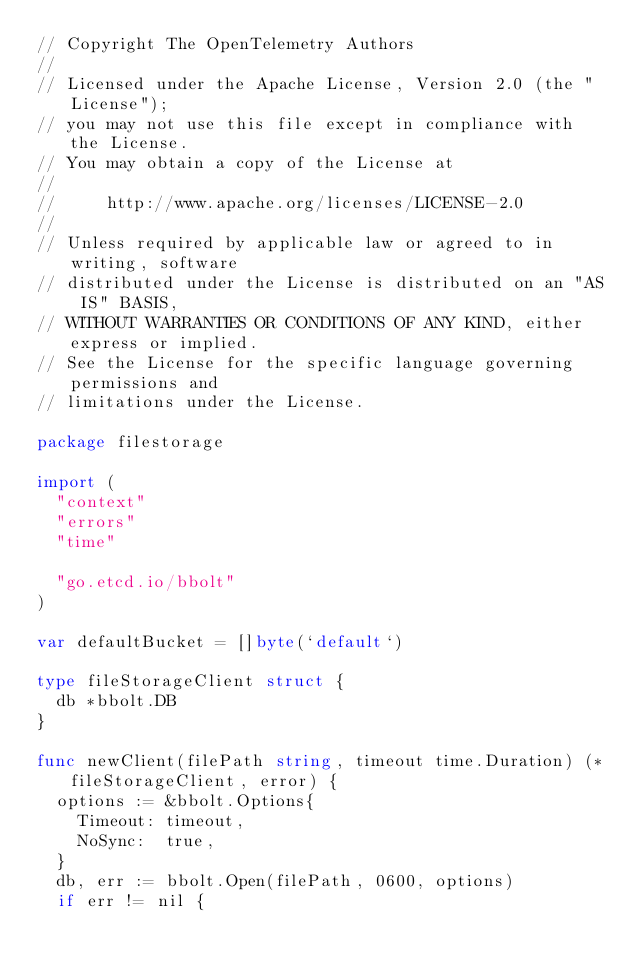<code> <loc_0><loc_0><loc_500><loc_500><_Go_>// Copyright The OpenTelemetry Authors
//
// Licensed under the Apache License, Version 2.0 (the "License");
// you may not use this file except in compliance with the License.
// You may obtain a copy of the License at
//
//     http://www.apache.org/licenses/LICENSE-2.0
//
// Unless required by applicable law or agreed to in writing, software
// distributed under the License is distributed on an "AS IS" BASIS,
// WITHOUT WARRANTIES OR CONDITIONS OF ANY KIND, either express or implied.
// See the License for the specific language governing permissions and
// limitations under the License.

package filestorage

import (
	"context"
	"errors"
	"time"

	"go.etcd.io/bbolt"
)

var defaultBucket = []byte(`default`)

type fileStorageClient struct {
	db *bbolt.DB
}

func newClient(filePath string, timeout time.Duration) (*fileStorageClient, error) {
	options := &bbolt.Options{
		Timeout: timeout,
		NoSync:  true,
	}
	db, err := bbolt.Open(filePath, 0600, options)
	if err != nil {</code> 